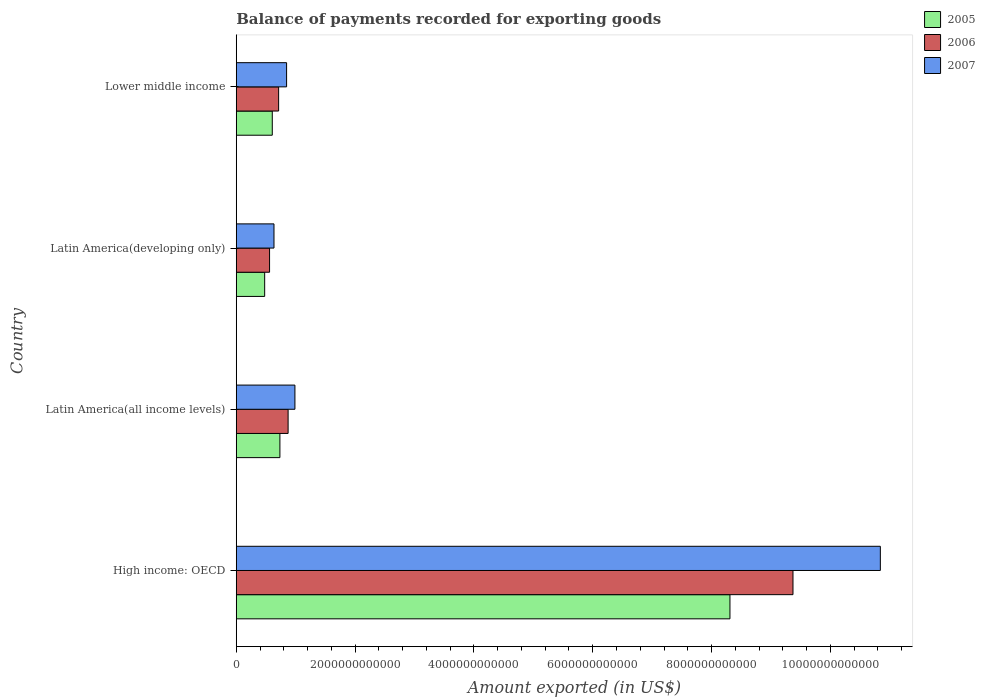How many different coloured bars are there?
Keep it short and to the point. 3. Are the number of bars per tick equal to the number of legend labels?
Make the answer very short. Yes. How many bars are there on the 1st tick from the top?
Provide a succinct answer. 3. What is the label of the 1st group of bars from the top?
Offer a very short reply. Lower middle income. What is the amount exported in 2006 in Latin America(all income levels)?
Provide a succinct answer. 8.73e+11. Across all countries, what is the maximum amount exported in 2005?
Give a very brief answer. 8.31e+12. Across all countries, what is the minimum amount exported in 2006?
Keep it short and to the point. 5.61e+11. In which country was the amount exported in 2005 maximum?
Your answer should be compact. High income: OECD. In which country was the amount exported in 2007 minimum?
Offer a terse response. Latin America(developing only). What is the total amount exported in 2007 in the graph?
Offer a very short reply. 1.33e+13. What is the difference between the amount exported in 2007 in Latin America(developing only) and that in Lower middle income?
Make the answer very short. -2.12e+11. What is the difference between the amount exported in 2006 in High income: OECD and the amount exported in 2005 in Latin America(developing only)?
Your response must be concise. 8.89e+12. What is the average amount exported in 2007 per country?
Give a very brief answer. 3.33e+12. What is the difference between the amount exported in 2005 and amount exported in 2007 in Latin America(developing only)?
Give a very brief answer. -1.57e+11. In how many countries, is the amount exported in 2006 greater than 8400000000000 US$?
Give a very brief answer. 1. What is the ratio of the amount exported in 2005 in Latin America(developing only) to that in Lower middle income?
Offer a terse response. 0.79. Is the amount exported in 2006 in Latin America(all income levels) less than that in Lower middle income?
Offer a terse response. No. Is the difference between the amount exported in 2005 in Latin America(all income levels) and Lower middle income greater than the difference between the amount exported in 2007 in Latin America(all income levels) and Lower middle income?
Offer a terse response. No. What is the difference between the highest and the second highest amount exported in 2005?
Ensure brevity in your answer.  7.58e+12. What is the difference between the highest and the lowest amount exported in 2005?
Offer a terse response. 7.83e+12. In how many countries, is the amount exported in 2006 greater than the average amount exported in 2006 taken over all countries?
Ensure brevity in your answer.  1. What does the 2nd bar from the bottom in Latin America(developing only) represents?
Your response must be concise. 2006. Is it the case that in every country, the sum of the amount exported in 2005 and amount exported in 2006 is greater than the amount exported in 2007?
Give a very brief answer. Yes. How many bars are there?
Your answer should be very brief. 12. Are all the bars in the graph horizontal?
Your answer should be compact. Yes. What is the difference between two consecutive major ticks on the X-axis?
Give a very brief answer. 2.00e+12. Does the graph contain any zero values?
Make the answer very short. No. Where does the legend appear in the graph?
Your answer should be compact. Top right. How many legend labels are there?
Offer a terse response. 3. What is the title of the graph?
Ensure brevity in your answer.  Balance of payments recorded for exporting goods. Does "1974" appear as one of the legend labels in the graph?
Offer a terse response. No. What is the label or title of the X-axis?
Your answer should be compact. Amount exported (in US$). What is the label or title of the Y-axis?
Keep it short and to the point. Country. What is the Amount exported (in US$) of 2005 in High income: OECD?
Make the answer very short. 8.31e+12. What is the Amount exported (in US$) in 2006 in High income: OECD?
Your response must be concise. 9.37e+12. What is the Amount exported (in US$) in 2007 in High income: OECD?
Offer a very short reply. 1.08e+13. What is the Amount exported (in US$) in 2005 in Latin America(all income levels)?
Keep it short and to the point. 7.35e+11. What is the Amount exported (in US$) of 2006 in Latin America(all income levels)?
Your response must be concise. 8.73e+11. What is the Amount exported (in US$) in 2007 in Latin America(all income levels)?
Provide a succinct answer. 9.87e+11. What is the Amount exported (in US$) in 2005 in Latin America(developing only)?
Make the answer very short. 4.78e+11. What is the Amount exported (in US$) of 2006 in Latin America(developing only)?
Provide a succinct answer. 5.61e+11. What is the Amount exported (in US$) in 2007 in Latin America(developing only)?
Give a very brief answer. 6.35e+11. What is the Amount exported (in US$) in 2005 in Lower middle income?
Make the answer very short. 6.06e+11. What is the Amount exported (in US$) of 2006 in Lower middle income?
Your response must be concise. 7.13e+11. What is the Amount exported (in US$) of 2007 in Lower middle income?
Keep it short and to the point. 8.47e+11. Across all countries, what is the maximum Amount exported (in US$) in 2005?
Ensure brevity in your answer.  8.31e+12. Across all countries, what is the maximum Amount exported (in US$) of 2006?
Keep it short and to the point. 9.37e+12. Across all countries, what is the maximum Amount exported (in US$) in 2007?
Ensure brevity in your answer.  1.08e+13. Across all countries, what is the minimum Amount exported (in US$) in 2005?
Give a very brief answer. 4.78e+11. Across all countries, what is the minimum Amount exported (in US$) of 2006?
Keep it short and to the point. 5.61e+11. Across all countries, what is the minimum Amount exported (in US$) of 2007?
Your response must be concise. 6.35e+11. What is the total Amount exported (in US$) in 2005 in the graph?
Offer a very short reply. 1.01e+13. What is the total Amount exported (in US$) in 2006 in the graph?
Keep it short and to the point. 1.15e+13. What is the total Amount exported (in US$) of 2007 in the graph?
Provide a short and direct response. 1.33e+13. What is the difference between the Amount exported (in US$) of 2005 in High income: OECD and that in Latin America(all income levels)?
Your answer should be compact. 7.58e+12. What is the difference between the Amount exported (in US$) in 2006 in High income: OECD and that in Latin America(all income levels)?
Ensure brevity in your answer.  8.50e+12. What is the difference between the Amount exported (in US$) in 2007 in High income: OECD and that in Latin America(all income levels)?
Offer a terse response. 9.85e+12. What is the difference between the Amount exported (in US$) of 2005 in High income: OECD and that in Latin America(developing only)?
Offer a very short reply. 7.83e+12. What is the difference between the Amount exported (in US$) in 2006 in High income: OECD and that in Latin America(developing only)?
Keep it short and to the point. 8.81e+12. What is the difference between the Amount exported (in US$) in 2007 in High income: OECD and that in Latin America(developing only)?
Offer a very short reply. 1.02e+13. What is the difference between the Amount exported (in US$) of 2005 in High income: OECD and that in Lower middle income?
Make the answer very short. 7.70e+12. What is the difference between the Amount exported (in US$) of 2006 in High income: OECD and that in Lower middle income?
Keep it short and to the point. 8.66e+12. What is the difference between the Amount exported (in US$) of 2007 in High income: OECD and that in Lower middle income?
Offer a terse response. 9.99e+12. What is the difference between the Amount exported (in US$) of 2005 in Latin America(all income levels) and that in Latin America(developing only)?
Your answer should be very brief. 2.57e+11. What is the difference between the Amount exported (in US$) in 2006 in Latin America(all income levels) and that in Latin America(developing only)?
Your response must be concise. 3.12e+11. What is the difference between the Amount exported (in US$) of 2007 in Latin America(all income levels) and that in Latin America(developing only)?
Provide a succinct answer. 3.52e+11. What is the difference between the Amount exported (in US$) in 2005 in Latin America(all income levels) and that in Lower middle income?
Provide a short and direct response. 1.28e+11. What is the difference between the Amount exported (in US$) of 2006 in Latin America(all income levels) and that in Lower middle income?
Keep it short and to the point. 1.60e+11. What is the difference between the Amount exported (in US$) in 2007 in Latin America(all income levels) and that in Lower middle income?
Provide a succinct answer. 1.40e+11. What is the difference between the Amount exported (in US$) of 2005 in Latin America(developing only) and that in Lower middle income?
Your answer should be compact. -1.28e+11. What is the difference between the Amount exported (in US$) in 2006 in Latin America(developing only) and that in Lower middle income?
Provide a succinct answer. -1.53e+11. What is the difference between the Amount exported (in US$) in 2007 in Latin America(developing only) and that in Lower middle income?
Provide a short and direct response. -2.12e+11. What is the difference between the Amount exported (in US$) of 2005 in High income: OECD and the Amount exported (in US$) of 2006 in Latin America(all income levels)?
Your response must be concise. 7.44e+12. What is the difference between the Amount exported (in US$) in 2005 in High income: OECD and the Amount exported (in US$) in 2007 in Latin America(all income levels)?
Give a very brief answer. 7.32e+12. What is the difference between the Amount exported (in US$) in 2006 in High income: OECD and the Amount exported (in US$) in 2007 in Latin America(all income levels)?
Give a very brief answer. 8.38e+12. What is the difference between the Amount exported (in US$) of 2005 in High income: OECD and the Amount exported (in US$) of 2006 in Latin America(developing only)?
Keep it short and to the point. 7.75e+12. What is the difference between the Amount exported (in US$) of 2005 in High income: OECD and the Amount exported (in US$) of 2007 in Latin America(developing only)?
Offer a terse response. 7.67e+12. What is the difference between the Amount exported (in US$) in 2006 in High income: OECD and the Amount exported (in US$) in 2007 in Latin America(developing only)?
Provide a short and direct response. 8.74e+12. What is the difference between the Amount exported (in US$) in 2005 in High income: OECD and the Amount exported (in US$) in 2006 in Lower middle income?
Provide a succinct answer. 7.60e+12. What is the difference between the Amount exported (in US$) of 2005 in High income: OECD and the Amount exported (in US$) of 2007 in Lower middle income?
Your answer should be very brief. 7.46e+12. What is the difference between the Amount exported (in US$) of 2006 in High income: OECD and the Amount exported (in US$) of 2007 in Lower middle income?
Provide a short and direct response. 8.52e+12. What is the difference between the Amount exported (in US$) of 2005 in Latin America(all income levels) and the Amount exported (in US$) of 2006 in Latin America(developing only)?
Your response must be concise. 1.74e+11. What is the difference between the Amount exported (in US$) of 2005 in Latin America(all income levels) and the Amount exported (in US$) of 2007 in Latin America(developing only)?
Ensure brevity in your answer.  9.97e+1. What is the difference between the Amount exported (in US$) of 2006 in Latin America(all income levels) and the Amount exported (in US$) of 2007 in Latin America(developing only)?
Your response must be concise. 2.38e+11. What is the difference between the Amount exported (in US$) in 2005 in Latin America(all income levels) and the Amount exported (in US$) in 2006 in Lower middle income?
Your response must be concise. 2.16e+1. What is the difference between the Amount exported (in US$) in 2005 in Latin America(all income levels) and the Amount exported (in US$) in 2007 in Lower middle income?
Ensure brevity in your answer.  -1.13e+11. What is the difference between the Amount exported (in US$) in 2006 in Latin America(all income levels) and the Amount exported (in US$) in 2007 in Lower middle income?
Ensure brevity in your answer.  2.53e+1. What is the difference between the Amount exported (in US$) in 2005 in Latin America(developing only) and the Amount exported (in US$) in 2006 in Lower middle income?
Offer a terse response. -2.35e+11. What is the difference between the Amount exported (in US$) in 2005 in Latin America(developing only) and the Amount exported (in US$) in 2007 in Lower middle income?
Provide a succinct answer. -3.69e+11. What is the difference between the Amount exported (in US$) in 2006 in Latin America(developing only) and the Amount exported (in US$) in 2007 in Lower middle income?
Keep it short and to the point. -2.87e+11. What is the average Amount exported (in US$) of 2005 per country?
Ensure brevity in your answer.  2.53e+12. What is the average Amount exported (in US$) in 2006 per country?
Ensure brevity in your answer.  2.88e+12. What is the average Amount exported (in US$) in 2007 per country?
Give a very brief answer. 3.33e+12. What is the difference between the Amount exported (in US$) of 2005 and Amount exported (in US$) of 2006 in High income: OECD?
Give a very brief answer. -1.06e+12. What is the difference between the Amount exported (in US$) of 2005 and Amount exported (in US$) of 2007 in High income: OECD?
Offer a terse response. -2.53e+12. What is the difference between the Amount exported (in US$) of 2006 and Amount exported (in US$) of 2007 in High income: OECD?
Provide a short and direct response. -1.47e+12. What is the difference between the Amount exported (in US$) of 2005 and Amount exported (in US$) of 2006 in Latin America(all income levels)?
Offer a very short reply. -1.38e+11. What is the difference between the Amount exported (in US$) of 2005 and Amount exported (in US$) of 2007 in Latin America(all income levels)?
Your response must be concise. -2.53e+11. What is the difference between the Amount exported (in US$) of 2006 and Amount exported (in US$) of 2007 in Latin America(all income levels)?
Your response must be concise. -1.15e+11. What is the difference between the Amount exported (in US$) in 2005 and Amount exported (in US$) in 2006 in Latin America(developing only)?
Ensure brevity in your answer.  -8.23e+1. What is the difference between the Amount exported (in US$) of 2005 and Amount exported (in US$) of 2007 in Latin America(developing only)?
Ensure brevity in your answer.  -1.57e+11. What is the difference between the Amount exported (in US$) in 2006 and Amount exported (in US$) in 2007 in Latin America(developing only)?
Provide a succinct answer. -7.45e+1. What is the difference between the Amount exported (in US$) in 2005 and Amount exported (in US$) in 2006 in Lower middle income?
Offer a very short reply. -1.07e+11. What is the difference between the Amount exported (in US$) in 2005 and Amount exported (in US$) in 2007 in Lower middle income?
Your answer should be very brief. -2.41e+11. What is the difference between the Amount exported (in US$) of 2006 and Amount exported (in US$) of 2007 in Lower middle income?
Provide a short and direct response. -1.34e+11. What is the ratio of the Amount exported (in US$) in 2005 in High income: OECD to that in Latin America(all income levels)?
Keep it short and to the point. 11.31. What is the ratio of the Amount exported (in US$) of 2006 in High income: OECD to that in Latin America(all income levels)?
Offer a terse response. 10.74. What is the ratio of the Amount exported (in US$) of 2007 in High income: OECD to that in Latin America(all income levels)?
Your response must be concise. 10.98. What is the ratio of the Amount exported (in US$) of 2005 in High income: OECD to that in Latin America(developing only)?
Keep it short and to the point. 17.37. What is the ratio of the Amount exported (in US$) in 2006 in High income: OECD to that in Latin America(developing only)?
Give a very brief answer. 16.71. What is the ratio of the Amount exported (in US$) in 2007 in High income: OECD to that in Latin America(developing only)?
Ensure brevity in your answer.  17.07. What is the ratio of the Amount exported (in US$) in 2005 in High income: OECD to that in Lower middle income?
Ensure brevity in your answer.  13.7. What is the ratio of the Amount exported (in US$) of 2006 in High income: OECD to that in Lower middle income?
Your answer should be compact. 13.14. What is the ratio of the Amount exported (in US$) of 2007 in High income: OECD to that in Lower middle income?
Your answer should be very brief. 12.79. What is the ratio of the Amount exported (in US$) of 2005 in Latin America(all income levels) to that in Latin America(developing only)?
Offer a very short reply. 1.54. What is the ratio of the Amount exported (in US$) of 2006 in Latin America(all income levels) to that in Latin America(developing only)?
Your answer should be very brief. 1.56. What is the ratio of the Amount exported (in US$) in 2007 in Latin America(all income levels) to that in Latin America(developing only)?
Provide a short and direct response. 1.55. What is the ratio of the Amount exported (in US$) of 2005 in Latin America(all income levels) to that in Lower middle income?
Provide a succinct answer. 1.21. What is the ratio of the Amount exported (in US$) of 2006 in Latin America(all income levels) to that in Lower middle income?
Give a very brief answer. 1.22. What is the ratio of the Amount exported (in US$) in 2007 in Latin America(all income levels) to that in Lower middle income?
Ensure brevity in your answer.  1.17. What is the ratio of the Amount exported (in US$) in 2005 in Latin America(developing only) to that in Lower middle income?
Offer a very short reply. 0.79. What is the ratio of the Amount exported (in US$) of 2006 in Latin America(developing only) to that in Lower middle income?
Your response must be concise. 0.79. What is the ratio of the Amount exported (in US$) of 2007 in Latin America(developing only) to that in Lower middle income?
Your response must be concise. 0.75. What is the difference between the highest and the second highest Amount exported (in US$) in 2005?
Your response must be concise. 7.58e+12. What is the difference between the highest and the second highest Amount exported (in US$) in 2006?
Keep it short and to the point. 8.50e+12. What is the difference between the highest and the second highest Amount exported (in US$) in 2007?
Your answer should be compact. 9.85e+12. What is the difference between the highest and the lowest Amount exported (in US$) in 2005?
Your response must be concise. 7.83e+12. What is the difference between the highest and the lowest Amount exported (in US$) of 2006?
Provide a succinct answer. 8.81e+12. What is the difference between the highest and the lowest Amount exported (in US$) in 2007?
Make the answer very short. 1.02e+13. 